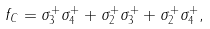Convert formula to latex. <formula><loc_0><loc_0><loc_500><loc_500>f _ { C } = \sigma _ { 3 } ^ { + } \sigma _ { 4 } ^ { + } + \sigma _ { 2 } ^ { + } \sigma _ { 3 } ^ { + } + \sigma _ { 2 } ^ { + } \sigma _ { 4 } ^ { + } ,</formula> 